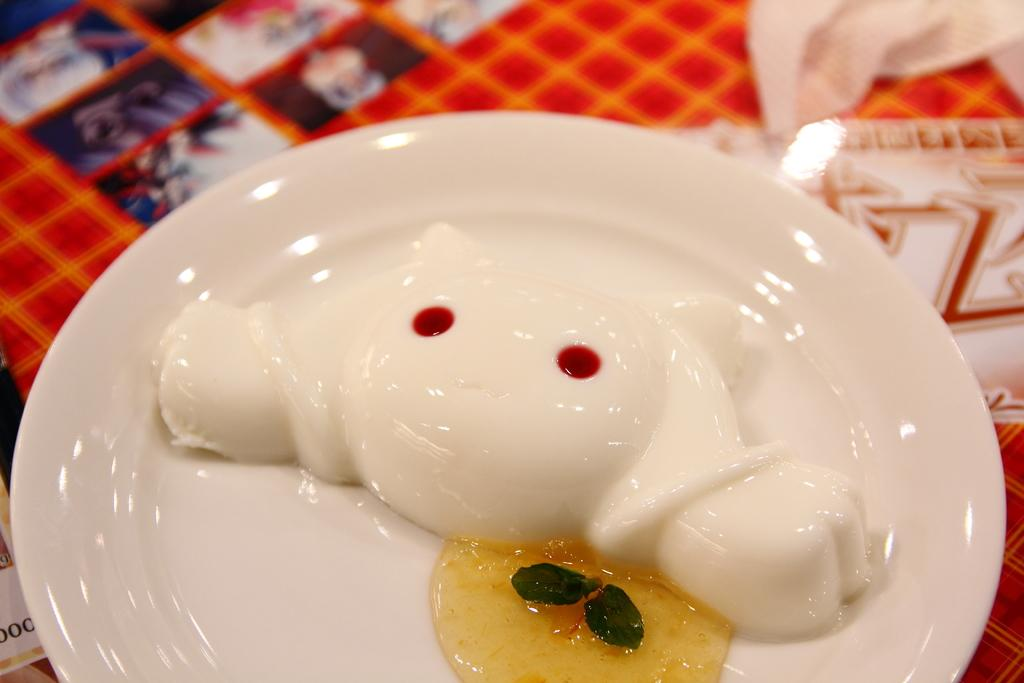What is the color of the plate in the image? The plate in the image is white. Where is the plate located? The plate is on an object. What is on top of the plate? There are food items on the plate. What type of twig can be seen supporting the plate in the image? There is no twig present in the image; the plate is on an object, but the nature of that object is not specified. 